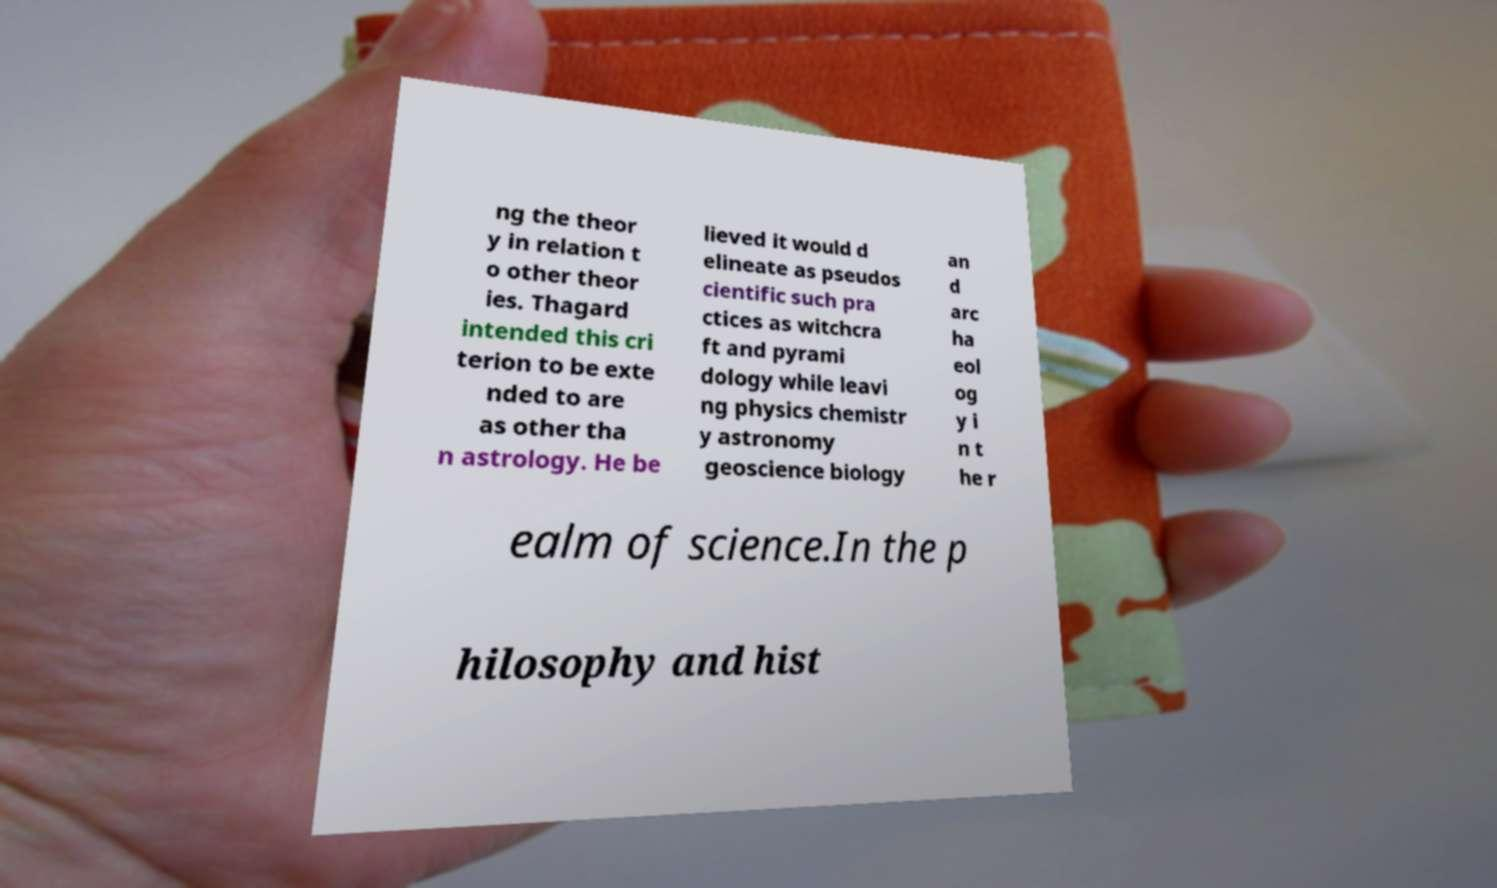For documentation purposes, I need the text within this image transcribed. Could you provide that? ng the theor y in relation t o other theor ies. Thagard intended this cri terion to be exte nded to are as other tha n astrology. He be lieved it would d elineate as pseudos cientific such pra ctices as witchcra ft and pyrami dology while leavi ng physics chemistr y astronomy geoscience biology an d arc ha eol og y i n t he r ealm of science.In the p hilosophy and hist 